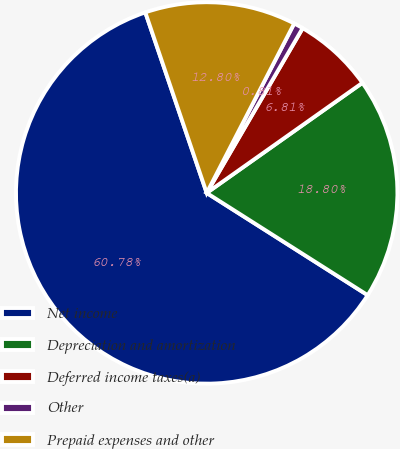<chart> <loc_0><loc_0><loc_500><loc_500><pie_chart><fcel>Net income<fcel>Depreciation and amortization<fcel>Deferred income taxes(a)<fcel>Other<fcel>Prepaid expenses and other<nl><fcel>60.78%<fcel>18.8%<fcel>6.81%<fcel>0.81%<fcel>12.8%<nl></chart> 